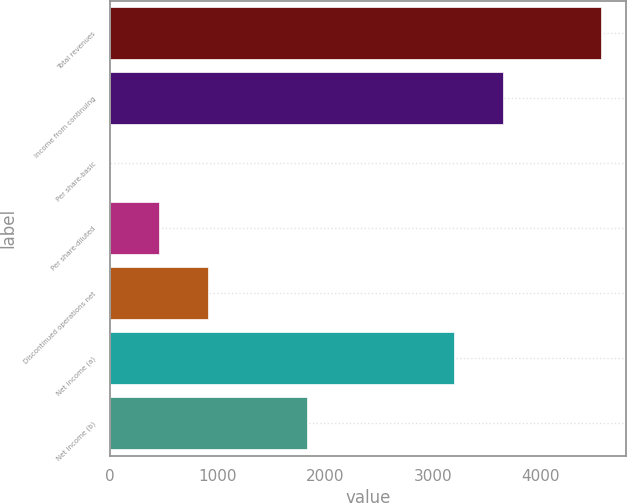Convert chart to OTSL. <chart><loc_0><loc_0><loc_500><loc_500><bar_chart><fcel>Total revenues<fcel>Income from continuing<fcel>Per share-basic<fcel>Per share-diluted<fcel>Discontinued operations net<fcel>Net income (a)<fcel>Net income (b)<nl><fcel>4567<fcel>3653.75<fcel>0.71<fcel>457.34<fcel>913.97<fcel>3197.12<fcel>1827.23<nl></chart> 